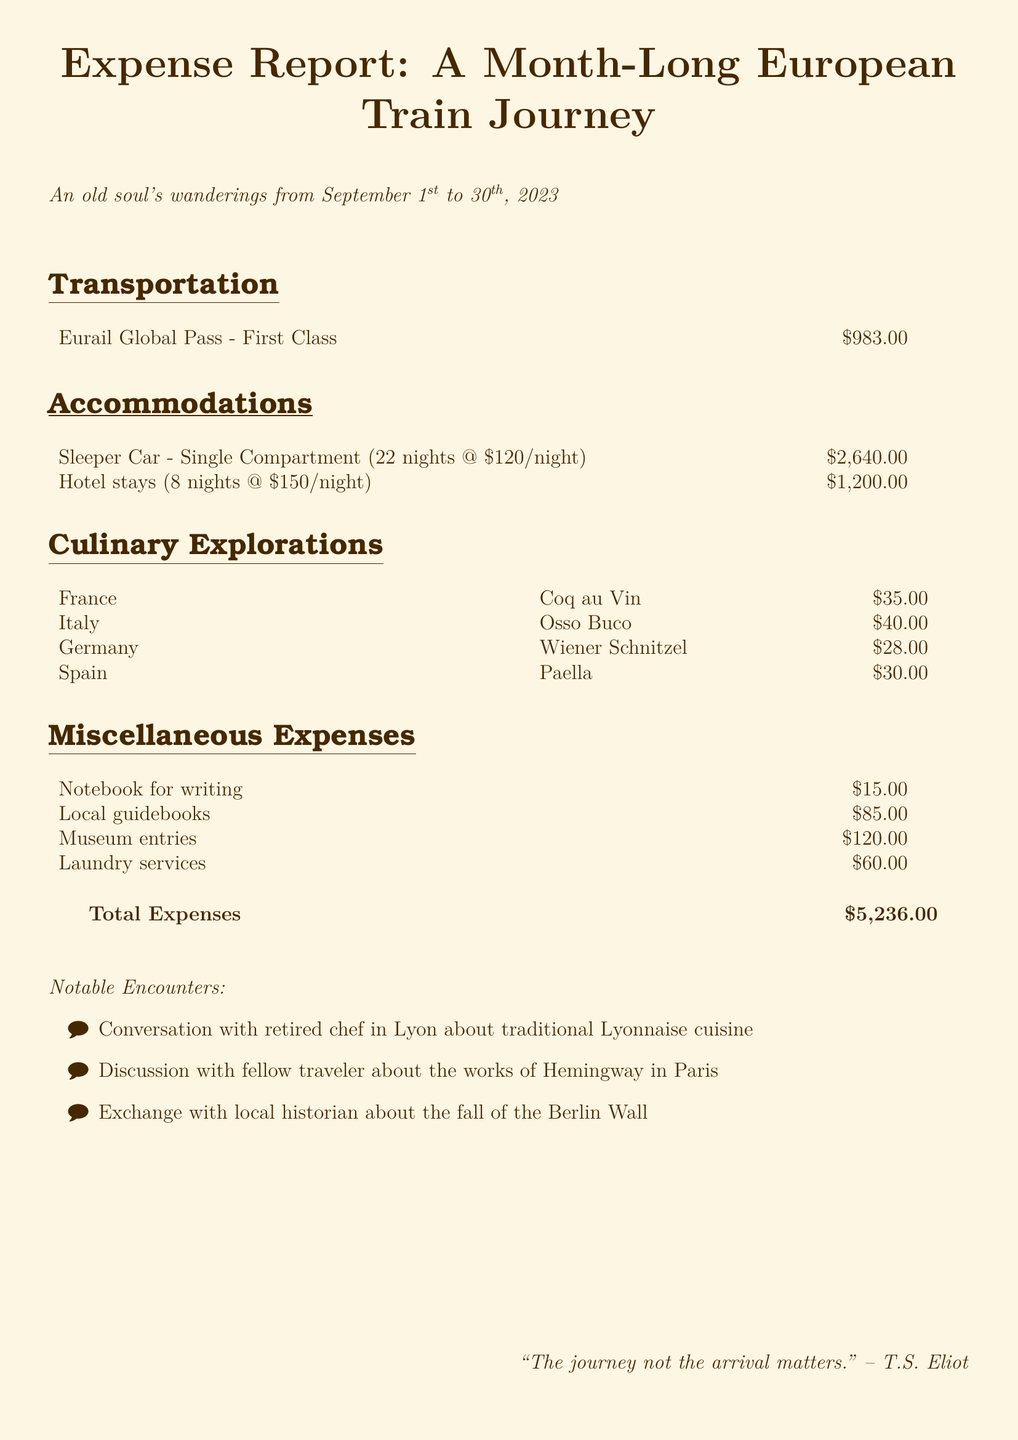What is the total cost of sleeper car accommodations? The total cost for sleeper car accommodations is calculated as 22 nights at $120 per night, which equals $2,640.
Answer: $2,640 What culinary exploration dish from Italy costs the most? The dish from Italy is Osso Buco, and its cost is listed as $40.
Answer: Osso Buco How many nights were spent in hotels? The document states 8 nights were spent in hotels.
Answer: 8 nights What was the cost of the Eurail Global Pass? The Eurail Global Pass cost is recorded as $983.00.
Answer: $983.00 What was the total amount spent on miscellaneous expenses? The total for miscellaneous expenses is calculated from various entries totaling $300.
Answer: $300 Which country’s cuisine features Coq au Vin? Coq au Vin is a cuisine dish listed under France.
Answer: France What is the date range of the journey? The journey took place from September 1st to 30th, 2023.
Answer: September 1st to 30th, 2023 How much was paid for laundry services? The cost for laundry services is noted as $60.
Answer: $60 What significant event was discussed with a local historian? The notable event discussed was the fall of the Berlin Wall.
Answer: fall of the Berlin Wall What is the total expense of the trip? The total expense calculated for the trip is $5,236.00.
Answer: $5,236.00 